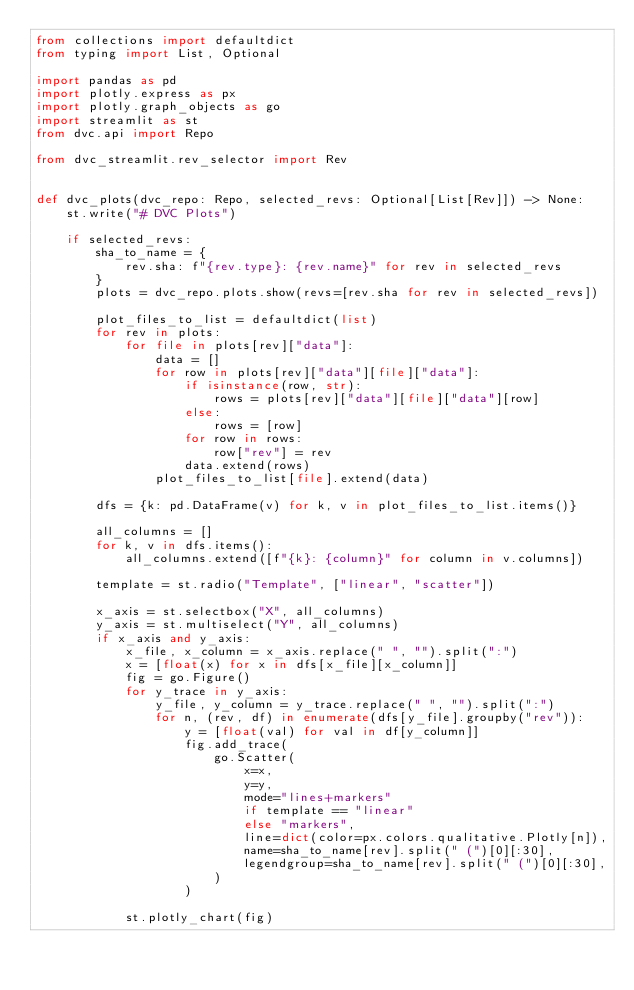<code> <loc_0><loc_0><loc_500><loc_500><_Python_>from collections import defaultdict
from typing import List, Optional

import pandas as pd
import plotly.express as px
import plotly.graph_objects as go
import streamlit as st
from dvc.api import Repo

from dvc_streamlit.rev_selector import Rev


def dvc_plots(dvc_repo: Repo, selected_revs: Optional[List[Rev]]) -> None:
    st.write("# DVC Plots")

    if selected_revs:
        sha_to_name = {
            rev.sha: f"{rev.type}: {rev.name}" for rev in selected_revs
        }
        plots = dvc_repo.plots.show(revs=[rev.sha for rev in selected_revs])

        plot_files_to_list = defaultdict(list)
        for rev in plots:
            for file in plots[rev]["data"]:
                data = []
                for row in plots[rev]["data"][file]["data"]:
                    if isinstance(row, str):
                        rows = plots[rev]["data"][file]["data"][row]
                    else:
                        rows = [row]
                    for row in rows:
                        row["rev"] = rev
                    data.extend(rows)
                plot_files_to_list[file].extend(data)

        dfs = {k: pd.DataFrame(v) for k, v in plot_files_to_list.items()}

        all_columns = []
        for k, v in dfs.items():
            all_columns.extend([f"{k}: {column}" for column in v.columns])

        template = st.radio("Template", ["linear", "scatter"])

        x_axis = st.selectbox("X", all_columns)
        y_axis = st.multiselect("Y", all_columns)
        if x_axis and y_axis:
            x_file, x_column = x_axis.replace(" ", "").split(":")
            x = [float(x) for x in dfs[x_file][x_column]]
            fig = go.Figure()
            for y_trace in y_axis:
                y_file, y_column = y_trace.replace(" ", "").split(":")
                for n, (rev, df) in enumerate(dfs[y_file].groupby("rev")):
                    y = [float(val) for val in df[y_column]]
                    fig.add_trace(
                        go.Scatter(
                            x=x,
                            y=y,
                            mode="lines+markers"
                            if template == "linear"
                            else "markers",
                            line=dict(color=px.colors.qualitative.Plotly[n]),
                            name=sha_to_name[rev].split(" (")[0][:30],
                            legendgroup=sha_to_name[rev].split(" (")[0][:30],
                        )
                    )

            st.plotly_chart(fig)
</code> 